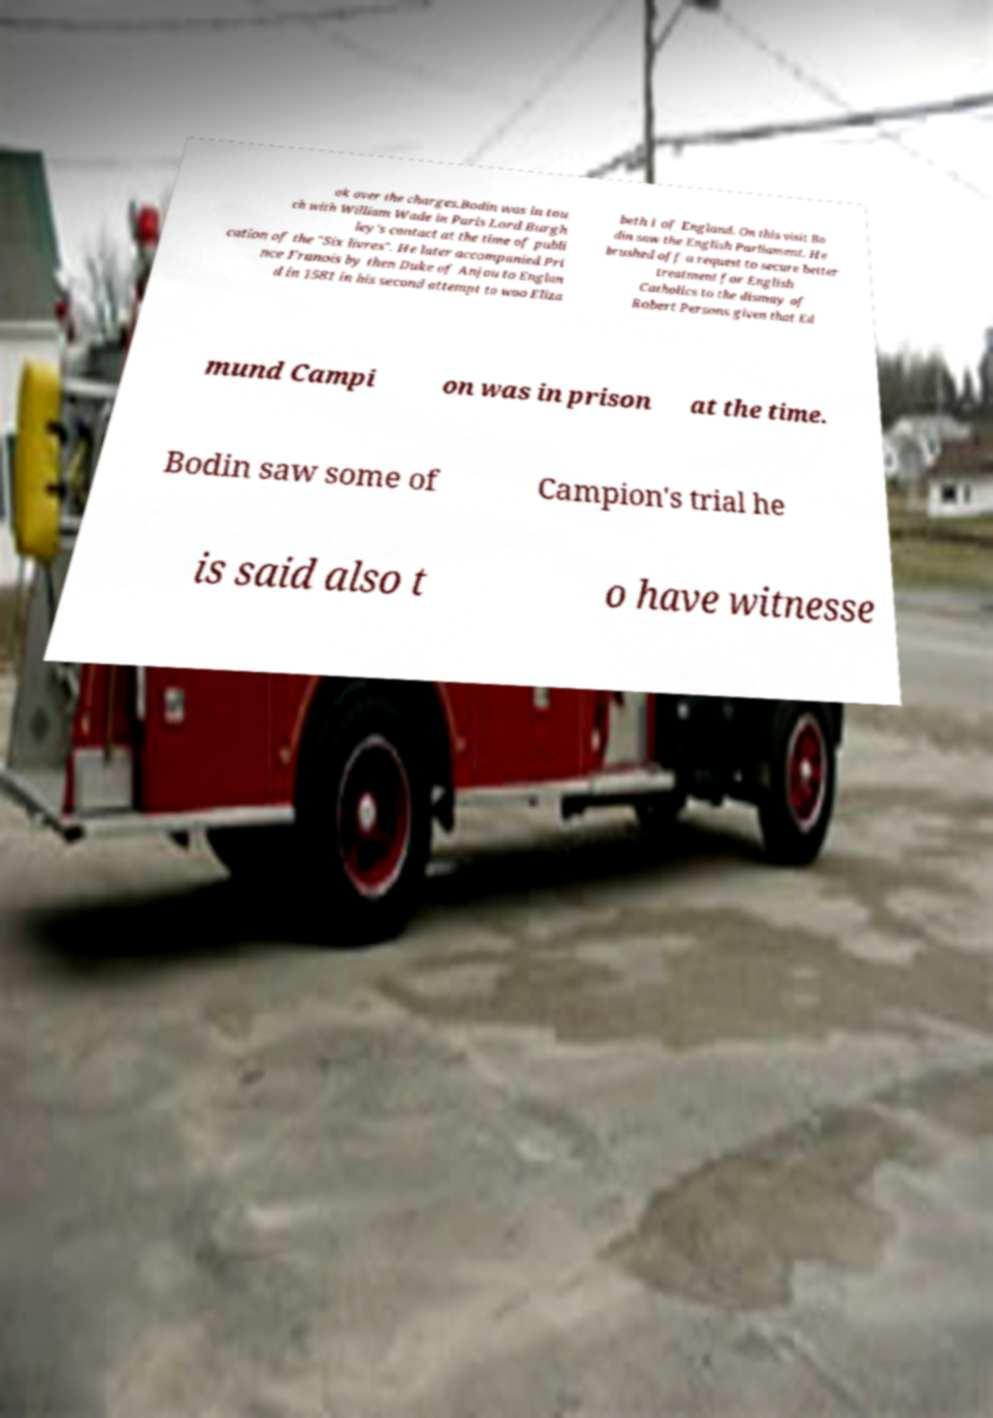Can you accurately transcribe the text from the provided image for me? ok over the charges.Bodin was in tou ch with William Wade in Paris Lord Burgh ley's contact at the time of publi cation of the "Six livres". He later accompanied Pri nce Franois by then Duke of Anjou to Englan d in 1581 in his second attempt to woo Eliza beth I of England. On this visit Bo din saw the English Parliament. He brushed off a request to secure better treatment for English Catholics to the dismay of Robert Persons given that Ed mund Campi on was in prison at the time. Bodin saw some of Campion's trial he is said also t o have witnesse 